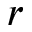Convert formula to latex. <formula><loc_0><loc_0><loc_500><loc_500>r</formula> 